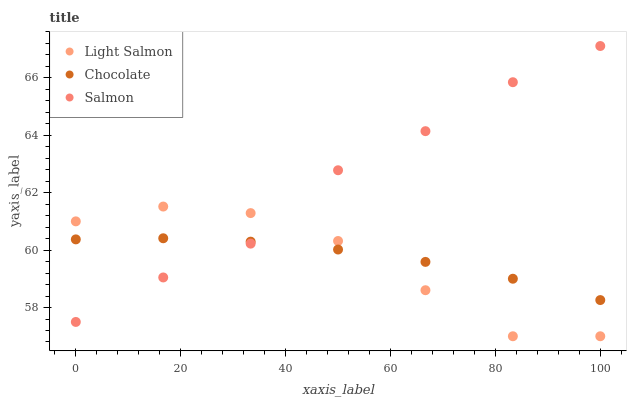Does Light Salmon have the minimum area under the curve?
Answer yes or no. Yes. Does Salmon have the maximum area under the curve?
Answer yes or no. Yes. Does Chocolate have the minimum area under the curve?
Answer yes or no. No. Does Chocolate have the maximum area under the curve?
Answer yes or no. No. Is Chocolate the smoothest?
Answer yes or no. Yes. Is Light Salmon the roughest?
Answer yes or no. Yes. Is Salmon the smoothest?
Answer yes or no. No. Is Salmon the roughest?
Answer yes or no. No. Does Light Salmon have the lowest value?
Answer yes or no. Yes. Does Salmon have the lowest value?
Answer yes or no. No. Does Salmon have the highest value?
Answer yes or no. Yes. Does Chocolate have the highest value?
Answer yes or no. No. Does Light Salmon intersect Chocolate?
Answer yes or no. Yes. Is Light Salmon less than Chocolate?
Answer yes or no. No. Is Light Salmon greater than Chocolate?
Answer yes or no. No. 